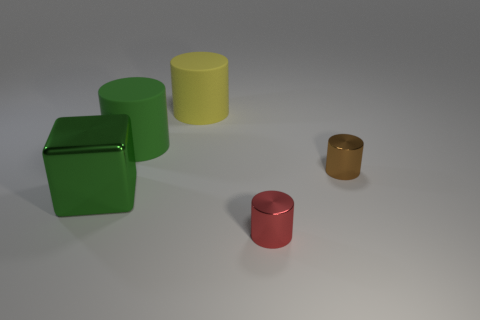Subtract 1 cylinders. How many cylinders are left? 3 Add 2 large green cylinders. How many objects exist? 7 Subtract all blocks. How many objects are left? 4 Subtract all tiny cylinders. Subtract all small red shiny cubes. How many objects are left? 3 Add 3 small brown objects. How many small brown objects are left? 4 Add 5 big yellow things. How many big yellow things exist? 6 Subtract 0 green spheres. How many objects are left? 5 